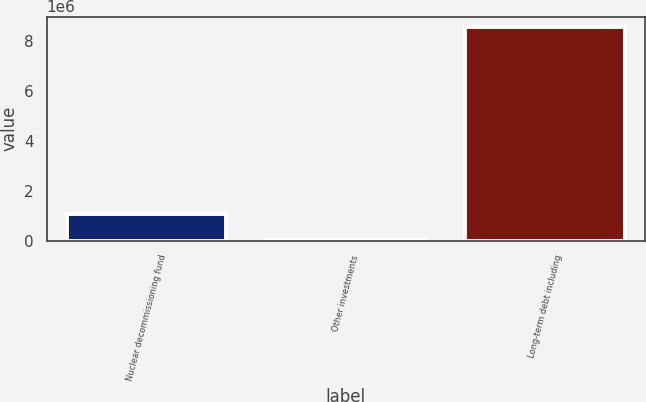<chart> <loc_0><loc_0><loc_500><loc_500><bar_chart><fcel>Nuclear decommissioning fund<fcel>Other investments<fcel>Long-term debt including<nl><fcel>1.07529e+06<fcel>9864<fcel>8.56228e+06<nl></chart> 